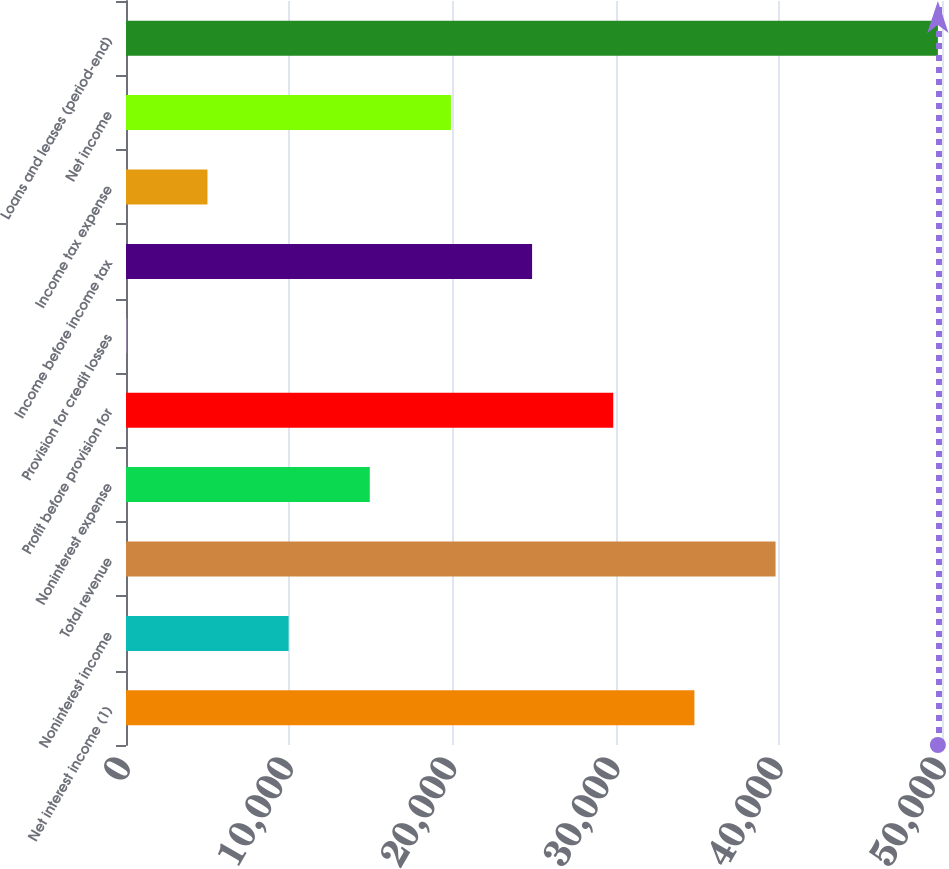Convert chart to OTSL. <chart><loc_0><loc_0><loc_500><loc_500><bar_chart><fcel>Net interest income (1)<fcel>Noninterest income<fcel>Total revenue<fcel>Noninterest expense<fcel>Profit before provision for<fcel>Provision for credit losses<fcel>Income before income tax<fcel>Income tax expense<fcel>Net income<fcel>Loans and leases (period-end)<nl><fcel>34828.6<fcel>9964.6<fcel>39801.4<fcel>14937.4<fcel>29855.8<fcel>19<fcel>24883<fcel>4991.8<fcel>19910.2<fcel>49747<nl></chart> 